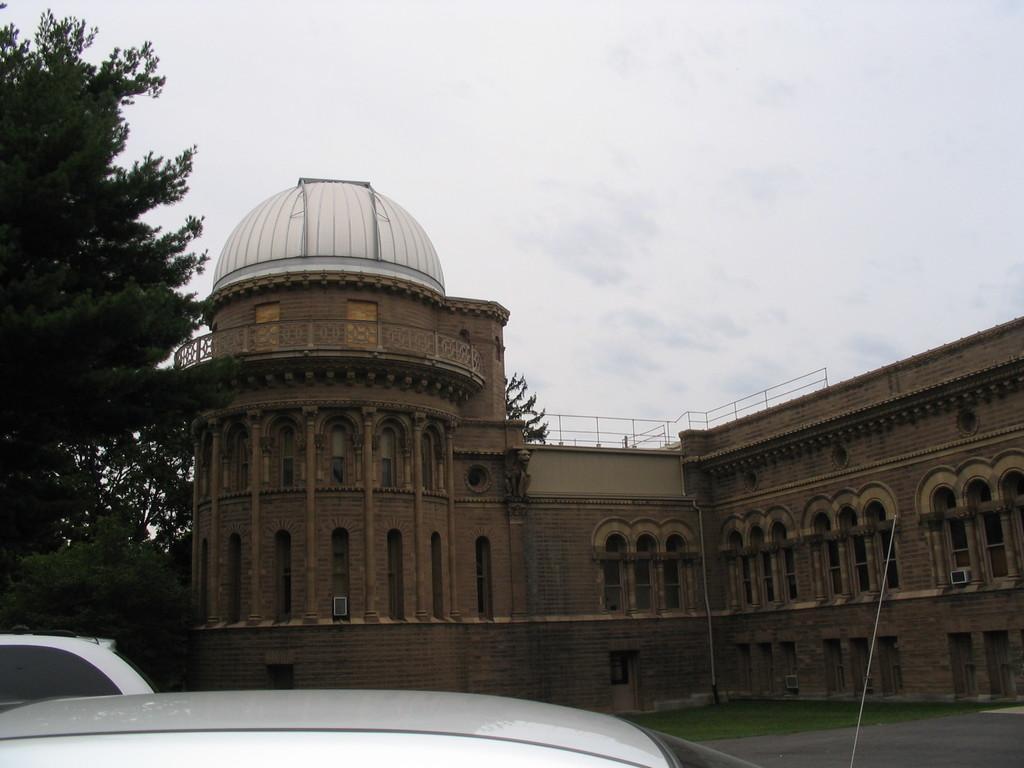Please provide a concise description of this image. In the center of the image we can see building. At the bottom of the image we can see cars on the road. In the background we can see trees and sky. 